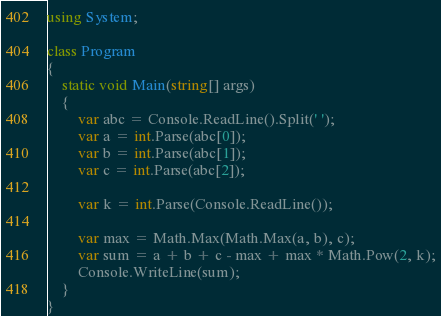<code> <loc_0><loc_0><loc_500><loc_500><_C#_>using System;

class Program
{
    static void Main(string[] args)
    {
        var abc = Console.ReadLine().Split(' ');
        var a = int.Parse(abc[0]);
        var b = int.Parse(abc[1]);
        var c = int.Parse(abc[2]);

        var k = int.Parse(Console.ReadLine());

        var max = Math.Max(Math.Max(a, b), c);
        var sum = a + b + c - max + max * Math.Pow(2, k);
        Console.WriteLine(sum);
    }
}
</code> 